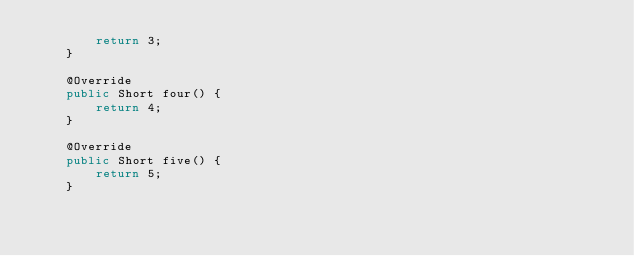<code> <loc_0><loc_0><loc_500><loc_500><_Java_>        return 3;
    }

    @Override
    public Short four() {
        return 4;
    }

    @Override
    public Short five() {
        return 5;
    }
</code> 